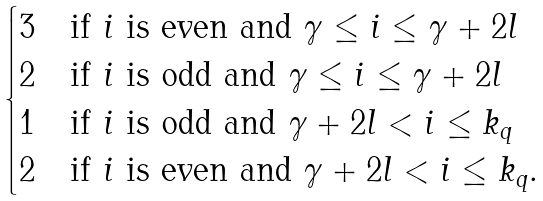<formula> <loc_0><loc_0><loc_500><loc_500>\begin{cases} 3 & \text {if $i$ is even and $\gamma \leq i \leq \gamma+2l$} \\ 2 & \text {if $i$ is odd and $\gamma \leq i \leq \gamma+2l$} \\ 1 & \text {if $i$ is odd and $\gamma+ 2l < i \leq k_{q}$} \\ 2 & \text {if $i$ is even and $\gamma+ 2l < i \leq k_{q}$.} \end{cases}</formula> 